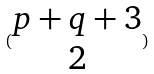Convert formula to latex. <formula><loc_0><loc_0><loc_500><loc_500>( \begin{matrix} p + q + 3 \\ 2 \end{matrix} )</formula> 